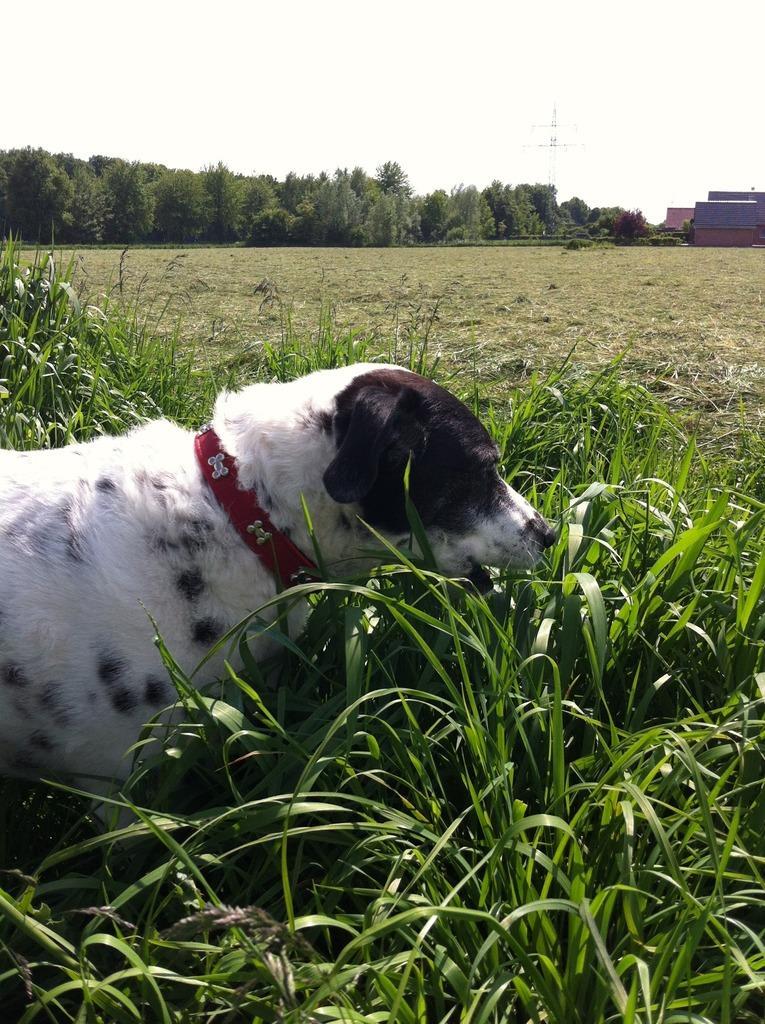Can you describe this image briefly? In the picture I can see a white color dog is standing in the grass. In the background, I can see houses, trees, tower and the plain sky. 